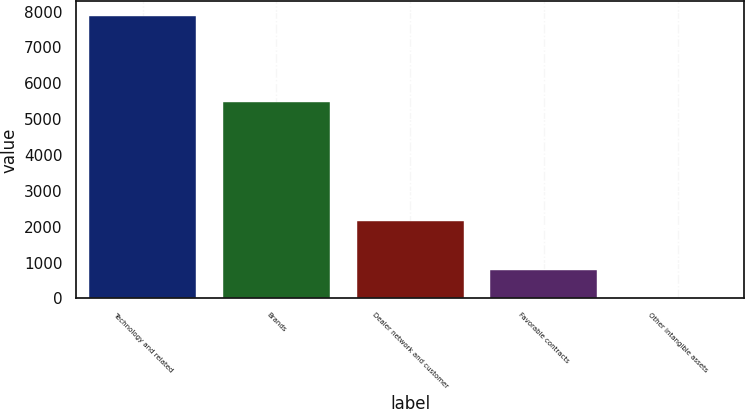Convert chart to OTSL. <chart><loc_0><loc_0><loc_500><loc_500><bar_chart><fcel>Technology and related<fcel>Brands<fcel>Dealer network and customer<fcel>Favorable contracts<fcel>Other intangible assets<nl><fcel>7889<fcel>5476<fcel>2149<fcel>804.2<fcel>17<nl></chart> 